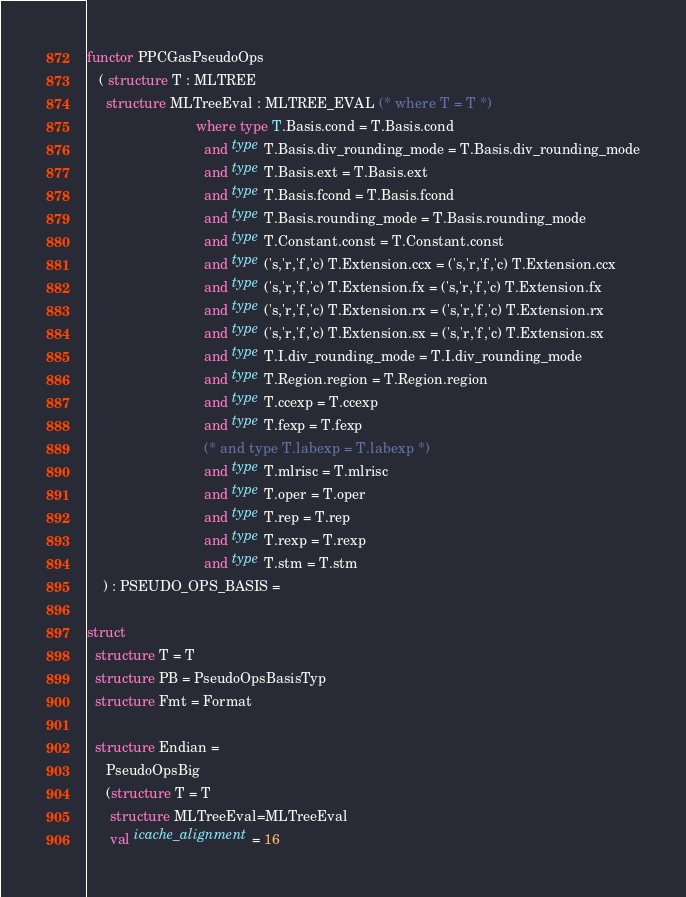<code> <loc_0><loc_0><loc_500><loc_500><_SML_>functor PPCGasPseudoOps 
   ( structure T : MLTREE
     structure MLTreeEval : MLTREE_EVAL (* where T = T *)
                            where type T.Basis.cond = T.Basis.cond
                              and type T.Basis.div_rounding_mode = T.Basis.div_rounding_mode
                              and type T.Basis.ext = T.Basis.ext
                              and type T.Basis.fcond = T.Basis.fcond
                              and type T.Basis.rounding_mode = T.Basis.rounding_mode
                              and type T.Constant.const = T.Constant.const
                              and type ('s,'r,'f,'c) T.Extension.ccx = ('s,'r,'f,'c) T.Extension.ccx
                              and type ('s,'r,'f,'c) T.Extension.fx = ('s,'r,'f,'c) T.Extension.fx
                              and type ('s,'r,'f,'c) T.Extension.rx = ('s,'r,'f,'c) T.Extension.rx
                              and type ('s,'r,'f,'c) T.Extension.sx = ('s,'r,'f,'c) T.Extension.sx
                              and type T.I.div_rounding_mode = T.I.div_rounding_mode
                              and type T.Region.region = T.Region.region
                              and type T.ccexp = T.ccexp
                              and type T.fexp = T.fexp
                              (* and type T.labexp = T.labexp *)
                              and type T.mlrisc = T.mlrisc
                              and type T.oper = T.oper
                              and type T.rep = T.rep
                              and type T.rexp = T.rexp
                              and type T.stm = T.stm
    ) : PSEUDO_OPS_BASIS = 

struct
  structure T = T
  structure PB = PseudoOpsBasisTyp
  structure Fmt = Format

  structure Endian = 
     PseudoOpsBig
	 (structure T = T
	  structure MLTreeEval=MLTreeEval
	  val icache_alignment = 16</code> 